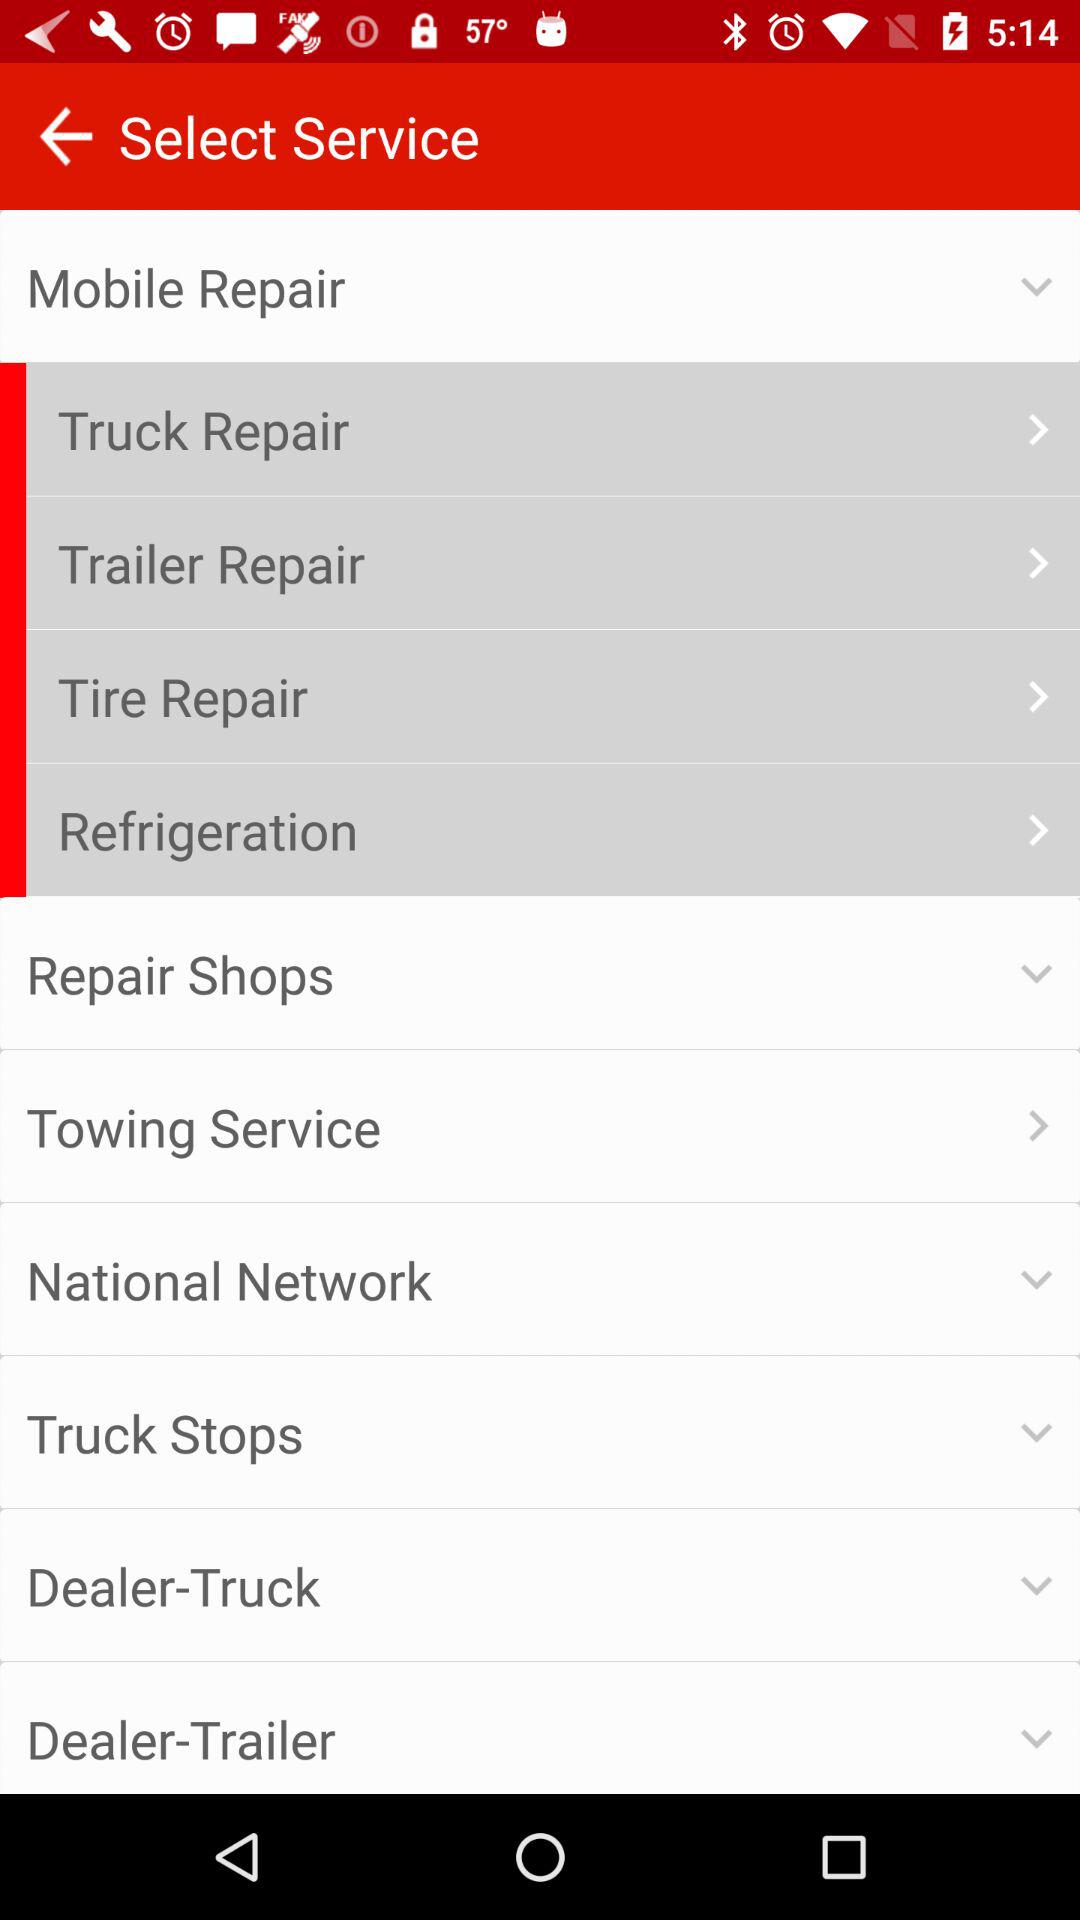What repair options are there in "Mobile Repair"? In "Mobile Repair," repair options are "Truck Repair", "Trailer Repair", "Tire Repair" and "Refrigeration". 